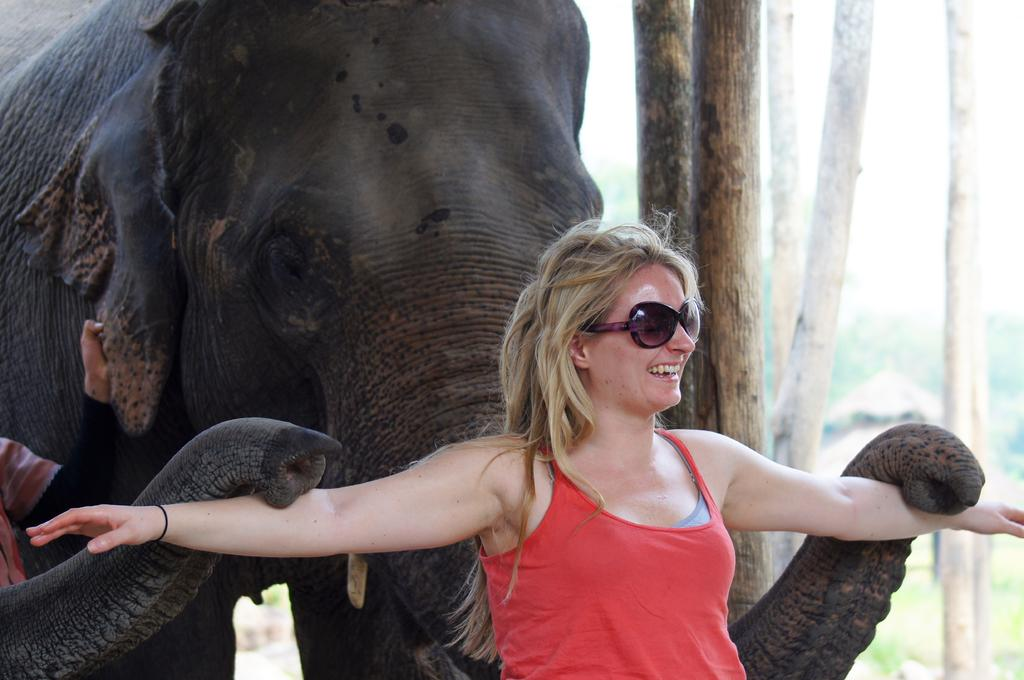Who is the main subject in the image? There is a woman standing in the middle of the image. What is the woman doing in the image? The woman is smiling. What is located behind the woman in the image? There is an elephant behind the woman. What type of natural environment is visible in the image? There are trees visible in the image. How many pies are being held by the horses in the image? There are no horses or pies present in the image. What is the temperature of the hot item visible in the image? There is no hot item visible in the image. 